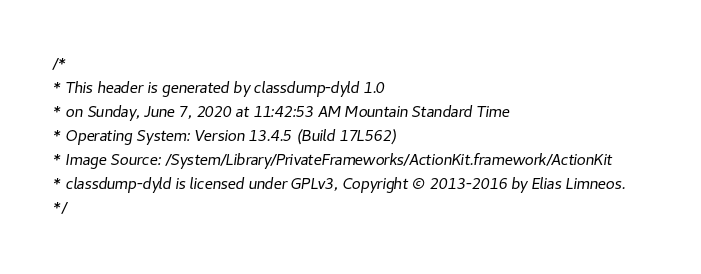Convert code to text. <code><loc_0><loc_0><loc_500><loc_500><_C_>/*
* This header is generated by classdump-dyld 1.0
* on Sunday, June 7, 2020 at 11:42:53 AM Mountain Standard Time
* Operating System: Version 13.4.5 (Build 17L562)
* Image Source: /System/Library/PrivateFrameworks/ActionKit.framework/ActionKit
* classdump-dyld is licensed under GPLv3, Copyright © 2013-2016 by Elias Limneos.
*/
</code> 